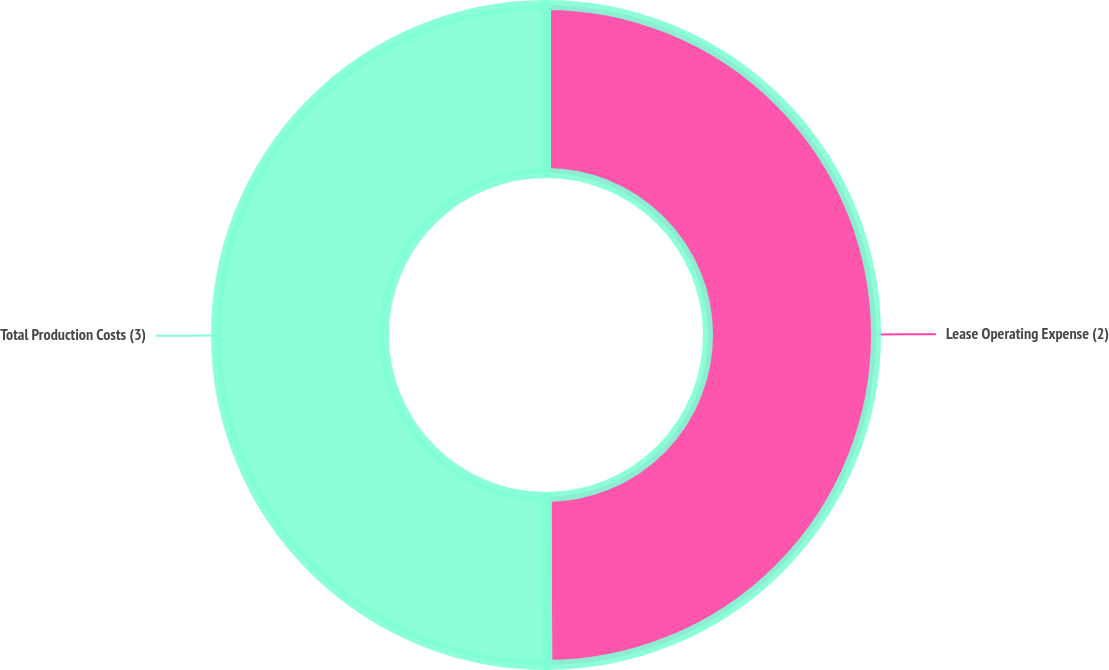Convert chart. <chart><loc_0><loc_0><loc_500><loc_500><pie_chart><fcel>Lease Operating Expense (2)<fcel>Total Production Costs (3)<nl><fcel>49.94%<fcel>50.06%<nl></chart> 